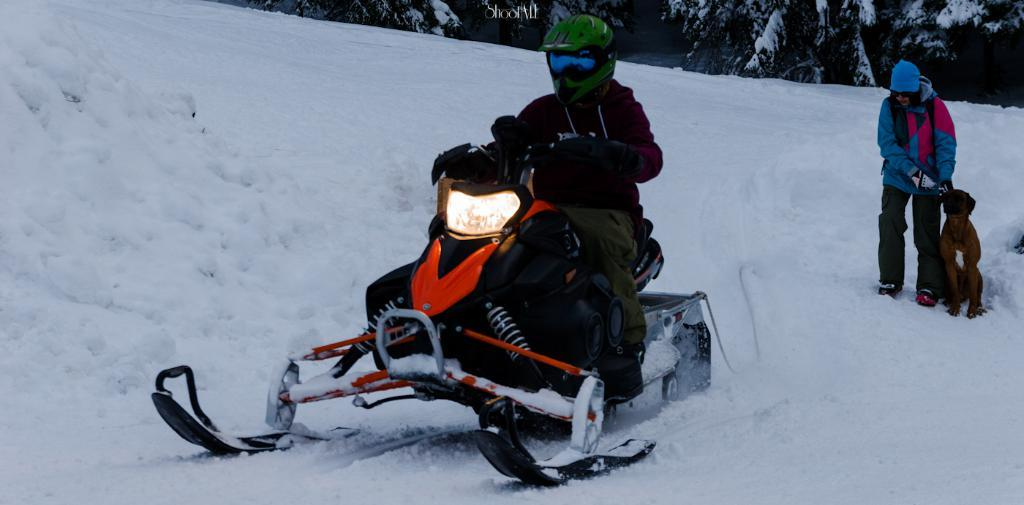What is the man doing in the image? The man is karting on the snow in the image. How many people are present in the image? There is one person, the man, in the image. What other living creature is present in the image? There is a dog on the snow in the image. What can be seen in the distance in the image? There are hills visible in the background of the image. What type of question is the dog asking in the image? There is no indication in the image that the dog is asking a question, as dogs do not have the ability to ask questions. 